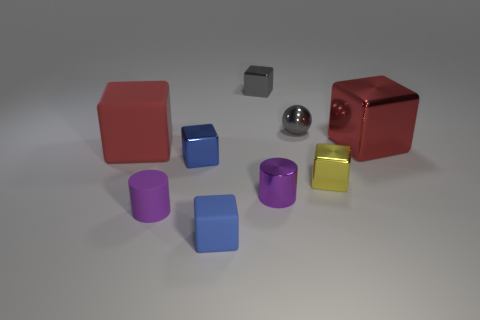Subtract 5 blocks. How many blocks are left? 1 Add 1 gray matte balls. How many objects exist? 10 Subtract all big shiny cubes. How many cubes are left? 5 Subtract all red cubes. How many cubes are left? 4 Subtract all cylinders. How many objects are left? 7 Add 3 gray metal objects. How many gray metal objects are left? 5 Add 7 large red shiny blocks. How many large red shiny blocks exist? 8 Subtract 0 blue cylinders. How many objects are left? 9 Subtract all green cylinders. Subtract all red blocks. How many cylinders are left? 2 Subtract all cyan blocks. How many blue cylinders are left? 0 